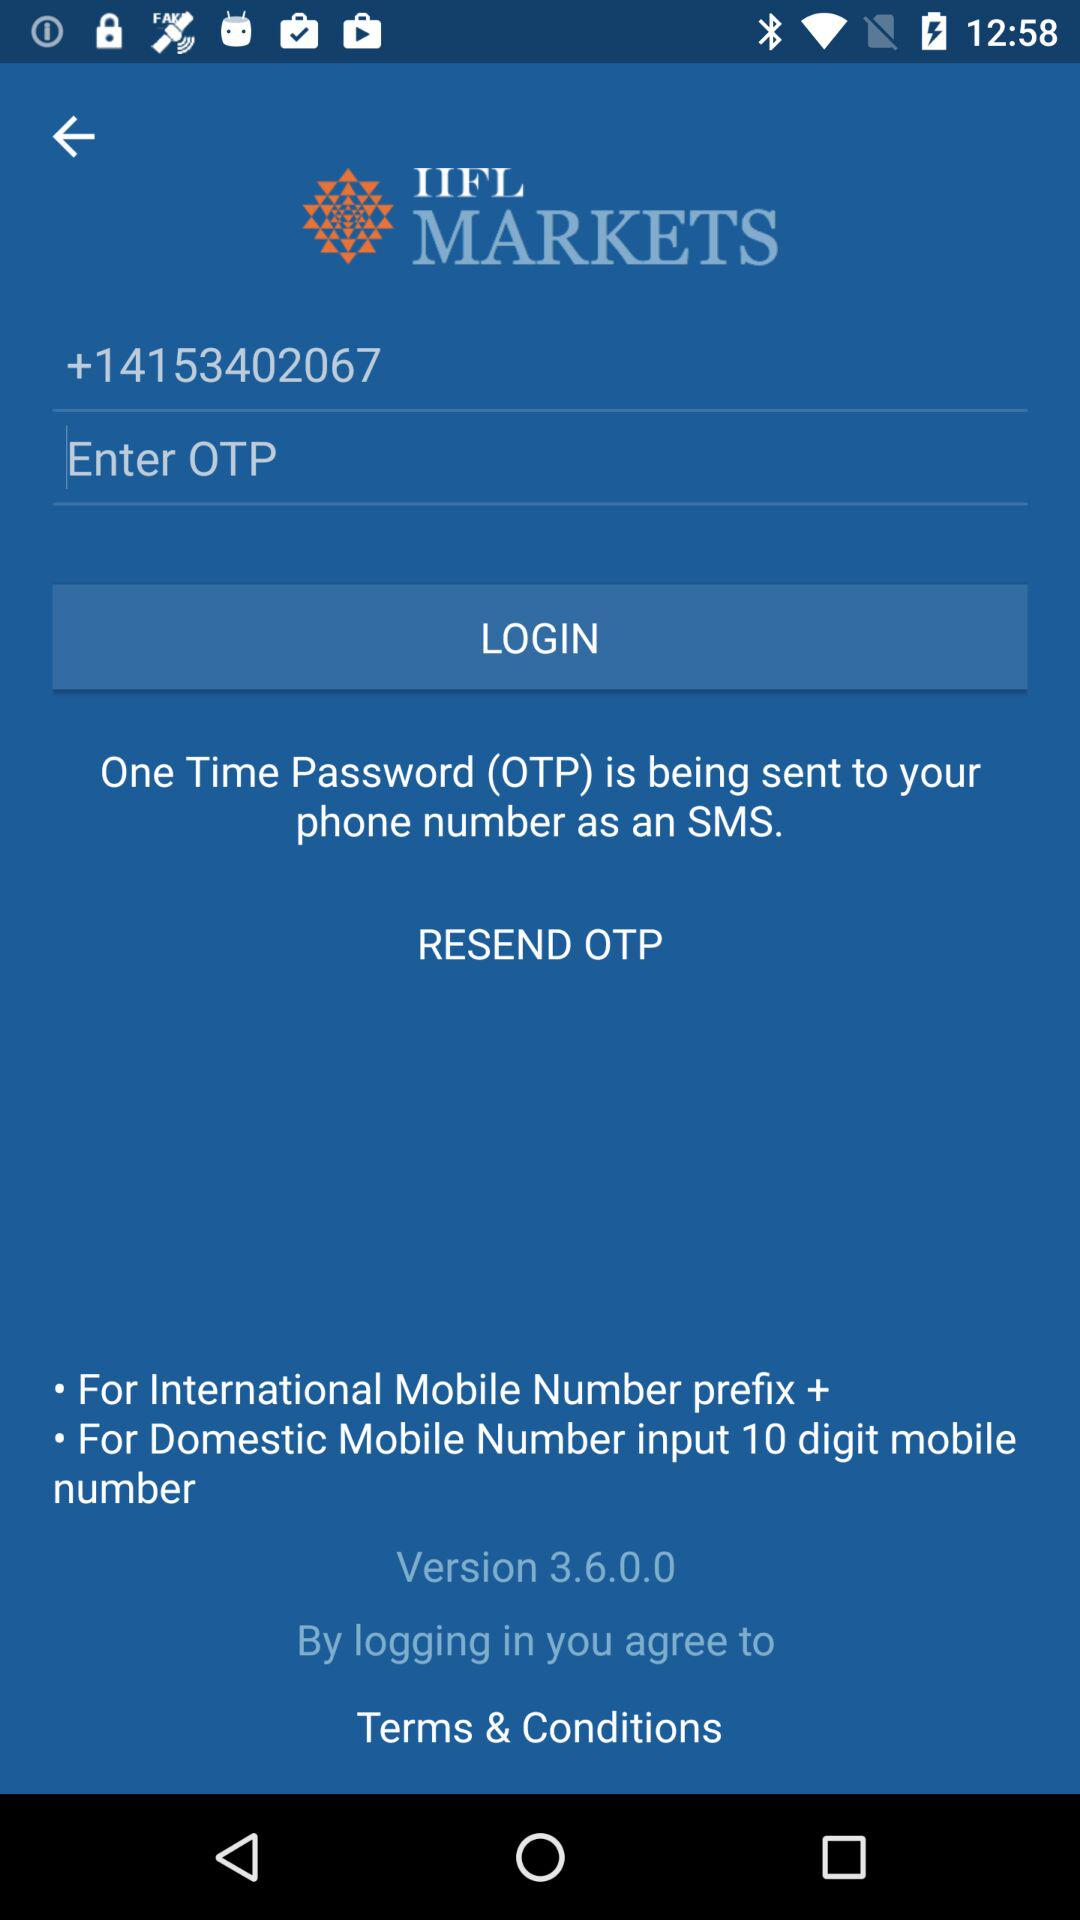What contact number is being used to log in to "IIFL MARKETS"? The contact number that is being used is +14153402067. 